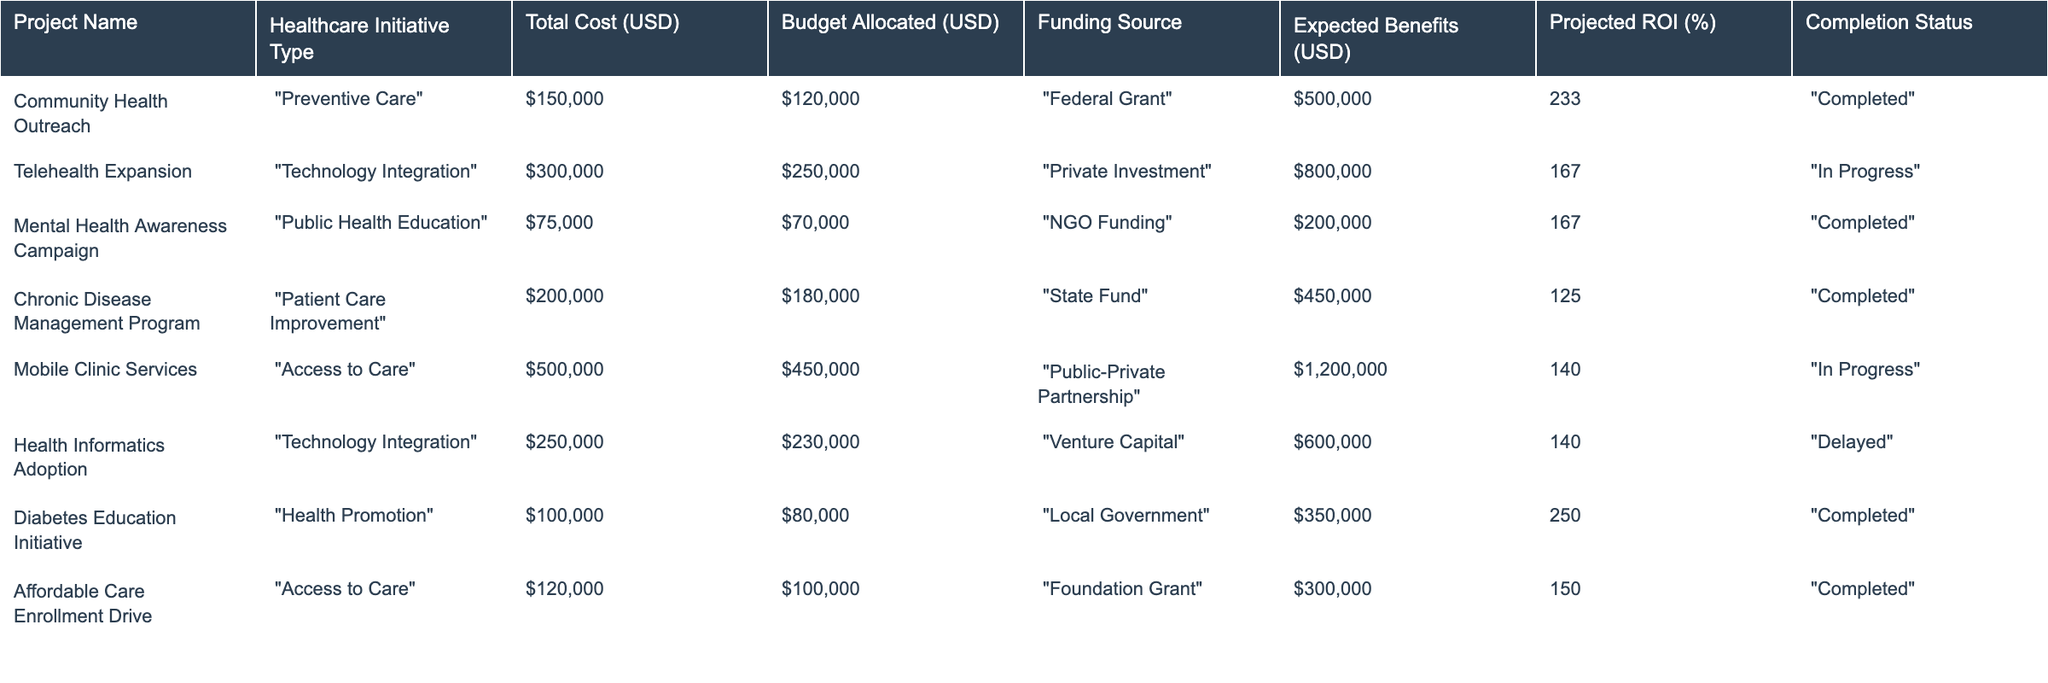What is the expected benefit of the "Chronic Disease Management Program"? In the table, the expected benefits for the "Chronic Disease Management Program" are listed as 450000 USD.
Answer: 450000 USD Which project has the highest total cost? By examining the "Total Cost (USD)" column, the "Mobile Clinic Services" project has the highest total cost of 500000 USD.
Answer: 500000 USD How many projects are currently "In Progress"? The table lists three projects with the completion status of "In Progress": "Telehealth Expansion", "Mobile Clinic Services", and "Health Informatics Adoption".
Answer: 3 What is the projected ROI percentage for the "Telehealth Expansion"? The projected ROI for "Telehealth Expansion" is stated as 167%.
Answer: 167% What is the difference between the budget allocated and the total cost for the "Mental Health Awareness Campaign"? The budget allocated is 70000 USD, and the total cost is 75000 USD. The difference is calculated as 75000 - 70000 = 5000 USD.
Answer: 5000 USD What is the total expected benefit for all completed projects? The expected benefits for completed projects are: 500000 (Community Health Outreach) + 200000 (Mental Health Awareness Campaign) + 450000 (Chronic Disease Management Program) + 350000 (Diabetes Education Initiative) + 300000 (Affordable Care Enrollment Drive) = 1900000 USD.
Answer: 1900000 USD Is the "Health Informatics Adoption" project completed? The completion status listed for "Health Informatics Adoption" is "Delayed," which means it is not completed.
Answer: No Which type of healthcare initiative has the highest average projected ROI? For "Preventive Care," the average projected ROI is 233%. For "Technology Integration," it is (167 + 140) / 2 = 153.5%. For "Public Health Education," it's 167%. For "Patient Care Improvement," it is 125%. For "Health Promotion," it's 250%. For "Access to Care," it is (150). Based on these calculations, "Health Promotion" has the highest average projected ROI.
Answer: Health Promotion What percentage of the budget was allocated to the project with the lowest expected benefits? The project with the lowest expected benefits is the "Mental Health Awareness Campaign" with 200000 USD. Its budget allocated is 70000 USD. The percentage allocated is (70000 / 200000) * 100 = 35%.
Answer: 35% 